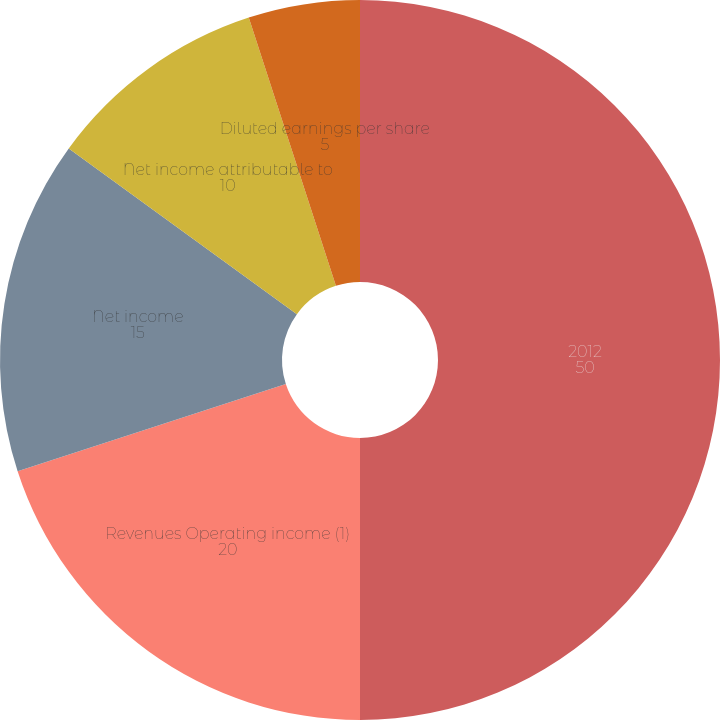Convert chart. <chart><loc_0><loc_0><loc_500><loc_500><pie_chart><fcel>2012<fcel>Revenues Operating income (1)<fcel>Net income<fcel>Net income attributable to<fcel>Basic earnings per share<fcel>Diluted earnings per share<nl><fcel>50.0%<fcel>20.0%<fcel>15.0%<fcel>10.0%<fcel>0.0%<fcel>5.0%<nl></chart> 